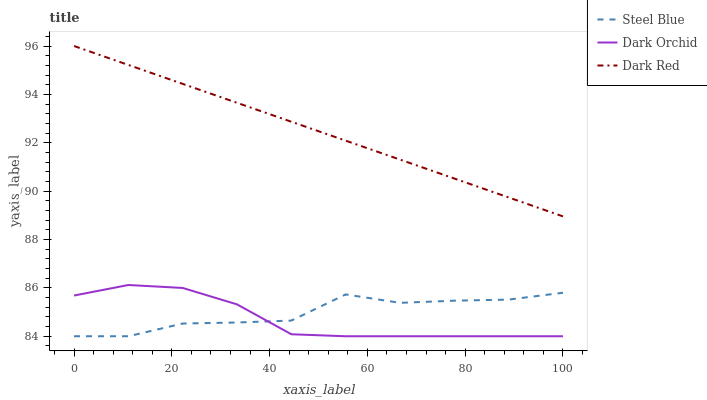Does Dark Orchid have the minimum area under the curve?
Answer yes or no. Yes. Does Dark Red have the maximum area under the curve?
Answer yes or no. Yes. Does Steel Blue have the minimum area under the curve?
Answer yes or no. No. Does Steel Blue have the maximum area under the curve?
Answer yes or no. No. Is Dark Red the smoothest?
Answer yes or no. Yes. Is Steel Blue the roughest?
Answer yes or no. Yes. Is Dark Orchid the smoothest?
Answer yes or no. No. Is Dark Orchid the roughest?
Answer yes or no. No. Does Steel Blue have the lowest value?
Answer yes or no. Yes. Does Dark Red have the highest value?
Answer yes or no. Yes. Does Dark Orchid have the highest value?
Answer yes or no. No. Is Steel Blue less than Dark Red?
Answer yes or no. Yes. Is Dark Red greater than Dark Orchid?
Answer yes or no. Yes. Does Steel Blue intersect Dark Orchid?
Answer yes or no. Yes. Is Steel Blue less than Dark Orchid?
Answer yes or no. No. Is Steel Blue greater than Dark Orchid?
Answer yes or no. No. Does Steel Blue intersect Dark Red?
Answer yes or no. No. 